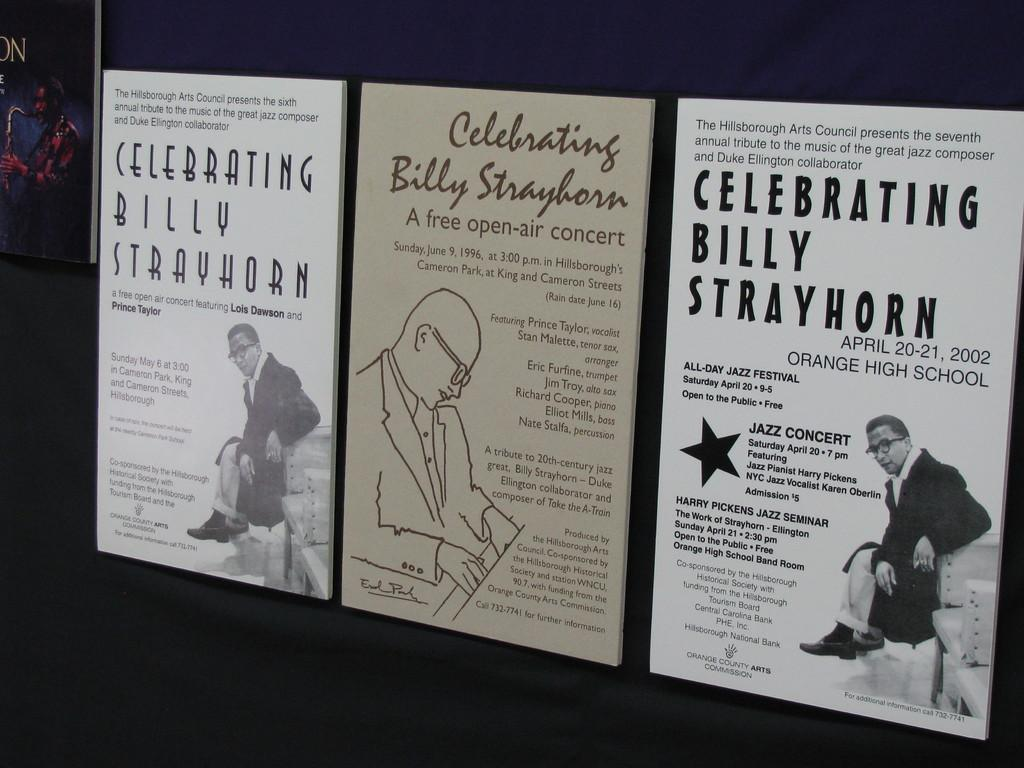Provide a one-sentence caption for the provided image. three posters for celebrating billy strayhorn on different days, may 6, june 9, and april 20-21. 